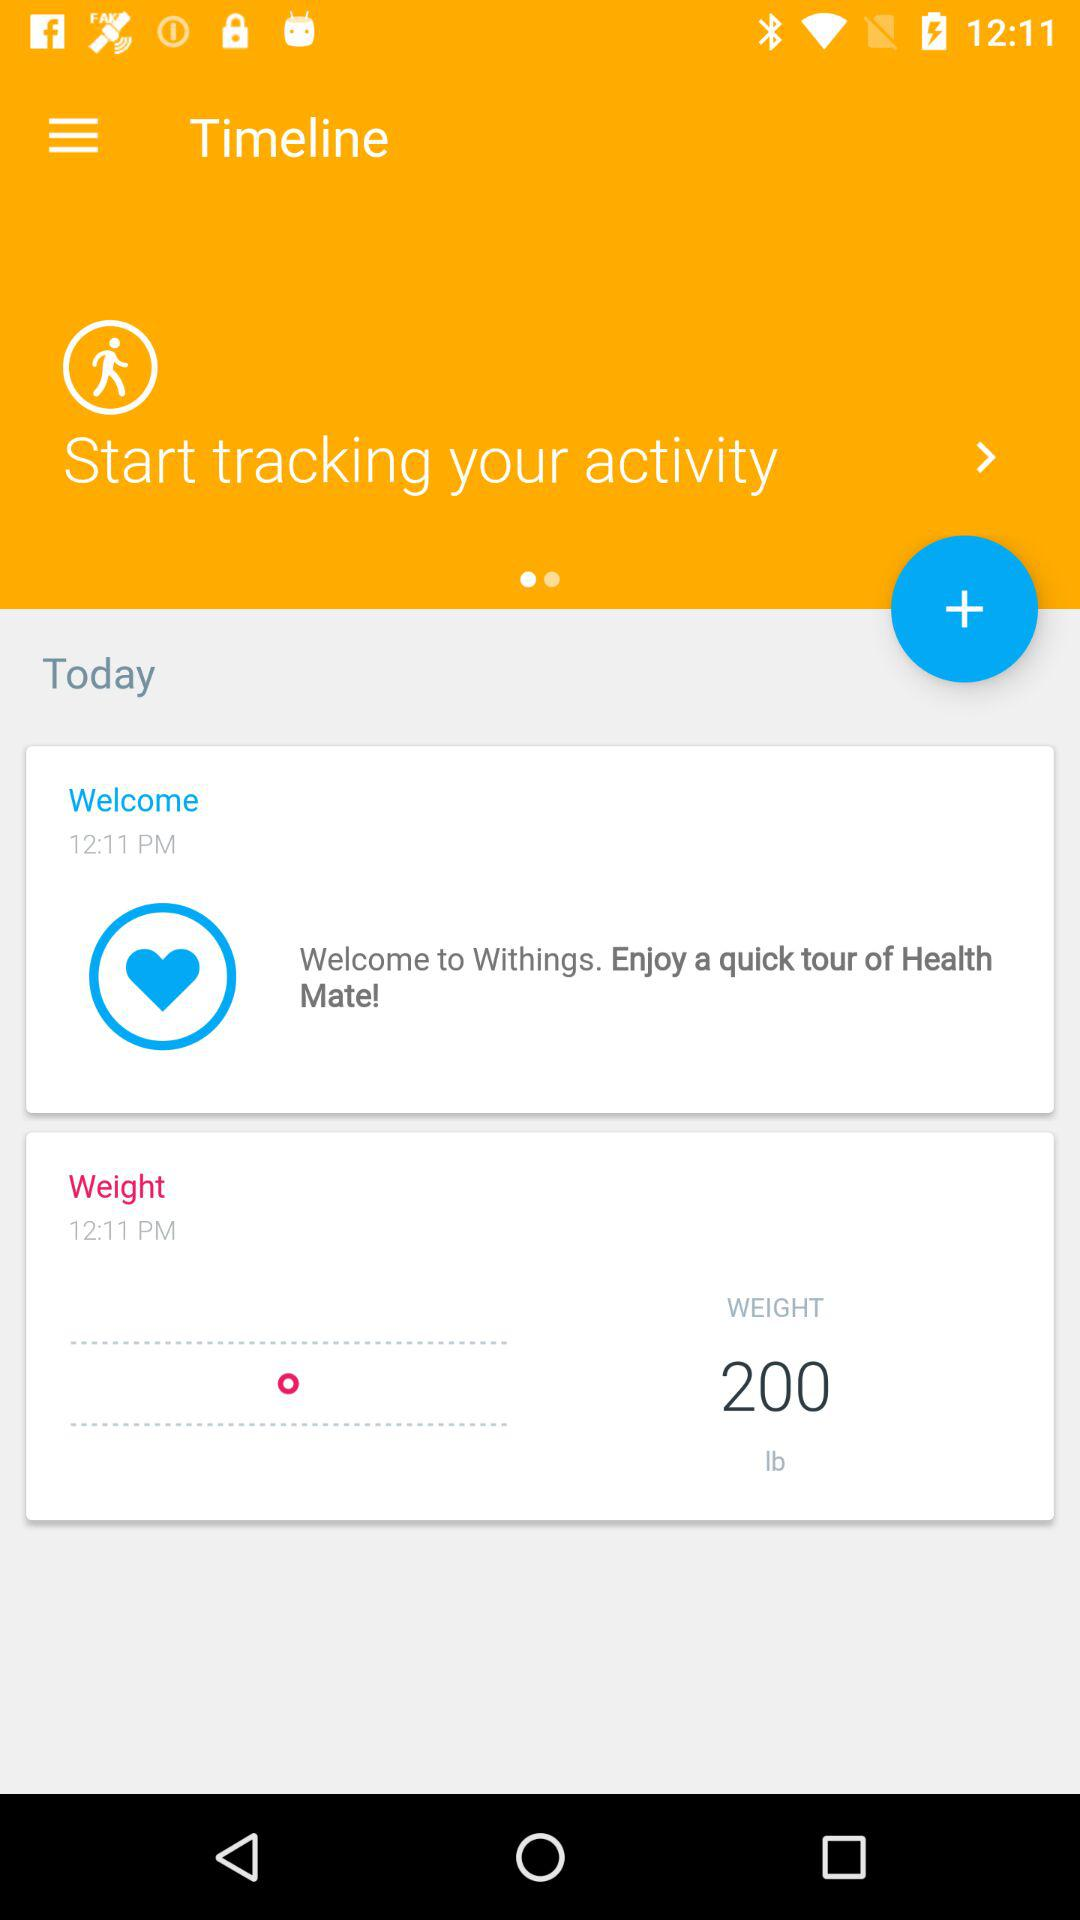How many pounds does the user weigh?
Answer the question using a single word or phrase. 200 